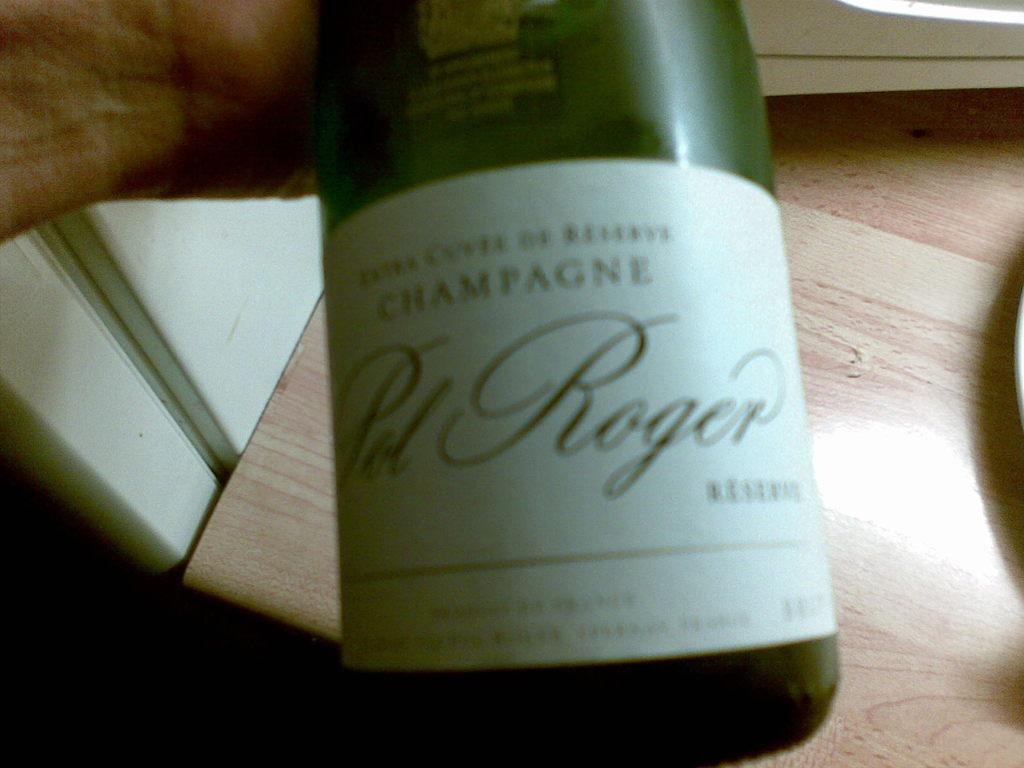Provide a one-sentence caption for the provided image. A person holding a bottle of Sol Roger champagne over a wood counter top. 